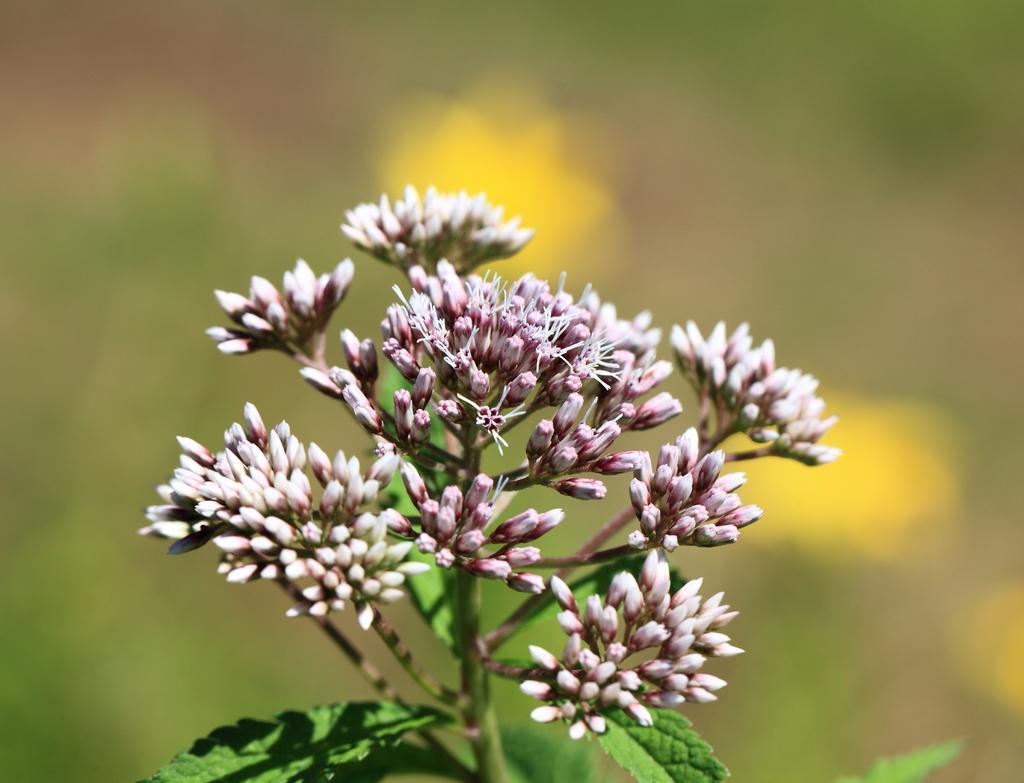How would you summarize this image in a sentence or two? There are flowers in the center of the image to a plant and the background is blurry. 